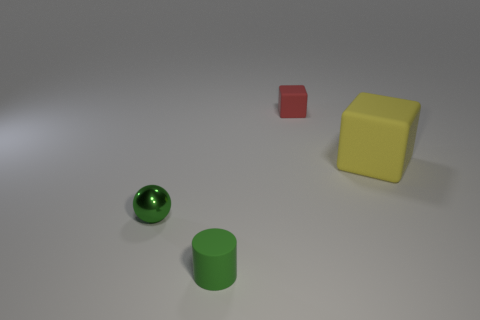Add 1 large cyan rubber blocks. How many objects exist? 5 Subtract all balls. How many objects are left? 3 Add 4 green cylinders. How many green cylinders are left? 5 Add 3 large red metallic cylinders. How many large red metallic cylinders exist? 3 Subtract 0 brown blocks. How many objects are left? 4 Subtract all yellow matte blocks. Subtract all cylinders. How many objects are left? 2 